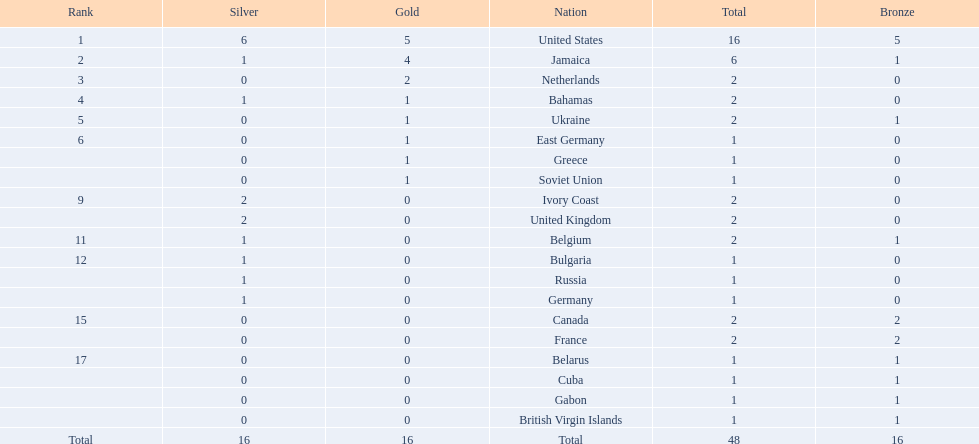What country won the most medals? United States. How many medals did the us win? 16. What is the most medals (after 16) that were won by a country? 6. Which country won 6 medals? Jamaica. 